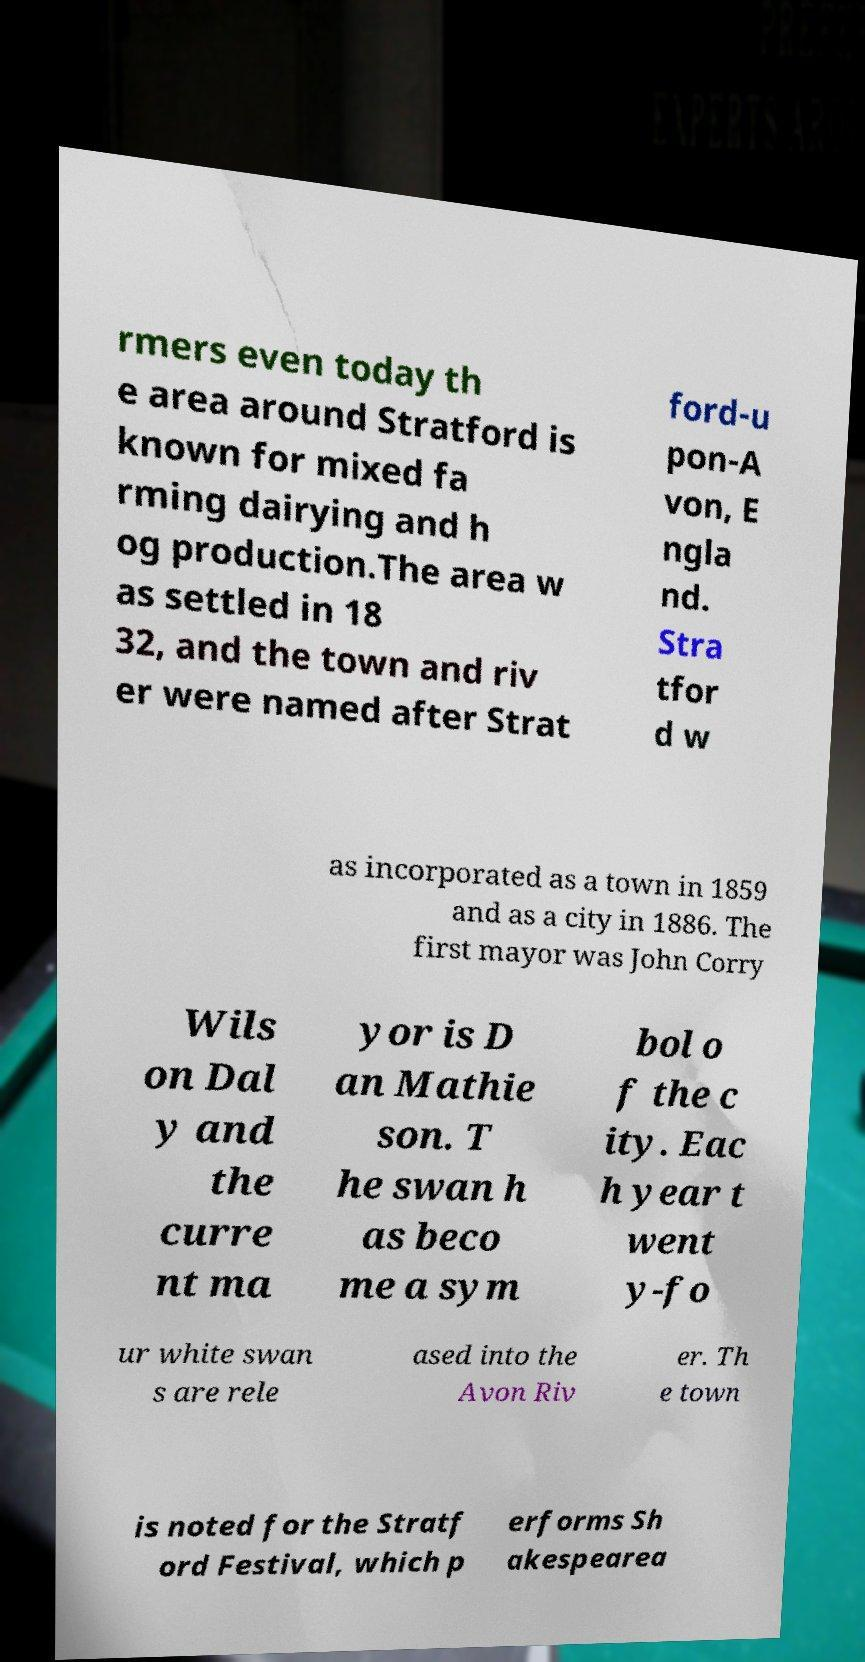Please read and relay the text visible in this image. What does it say? rmers even today th e area around Stratford is known for mixed fa rming dairying and h og production.The area w as settled in 18 32, and the town and riv er were named after Strat ford-u pon-A von, E ngla nd. Stra tfor d w as incorporated as a town in 1859 and as a city in 1886. The first mayor was John Corry Wils on Dal y and the curre nt ma yor is D an Mathie son. T he swan h as beco me a sym bol o f the c ity. Eac h year t went y-fo ur white swan s are rele ased into the Avon Riv er. Th e town is noted for the Stratf ord Festival, which p erforms Sh akespearea 